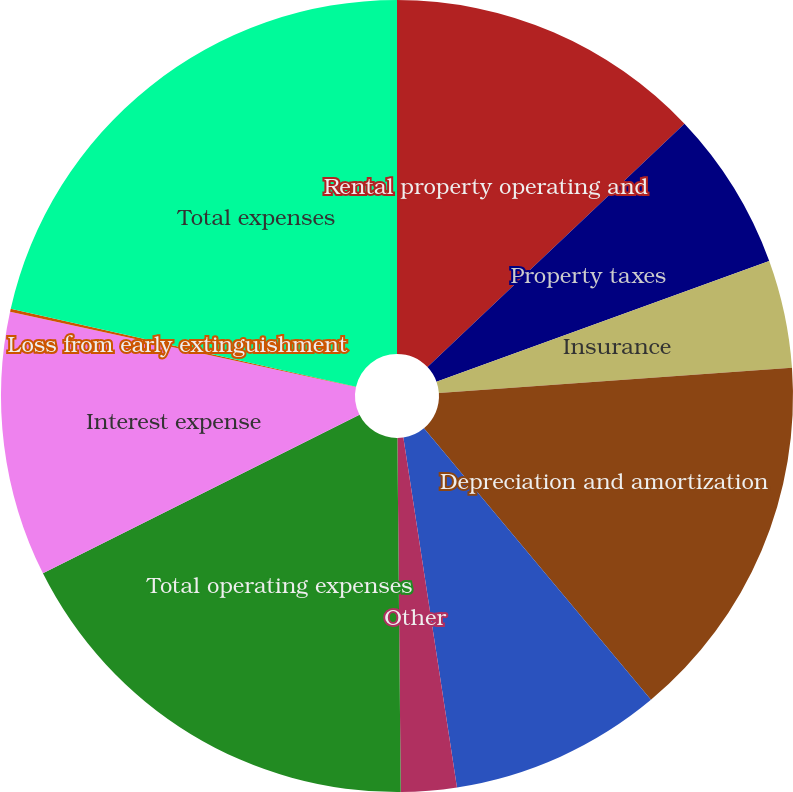<chart> <loc_0><loc_0><loc_500><loc_500><pie_chart><fcel>Rental property operating and<fcel>Property taxes<fcel>Insurance<fcel>Depreciation and amortization<fcel>General and administrative<fcel>Other<fcel>Total operating expenses<fcel>Interest expense<fcel>Loss from early extinguishment<fcel>Total expenses<nl><fcel>12.93%<fcel>6.53%<fcel>4.4%<fcel>15.06%<fcel>8.66%<fcel>2.27%<fcel>17.76%<fcel>10.8%<fcel>0.13%<fcel>21.46%<nl></chart> 